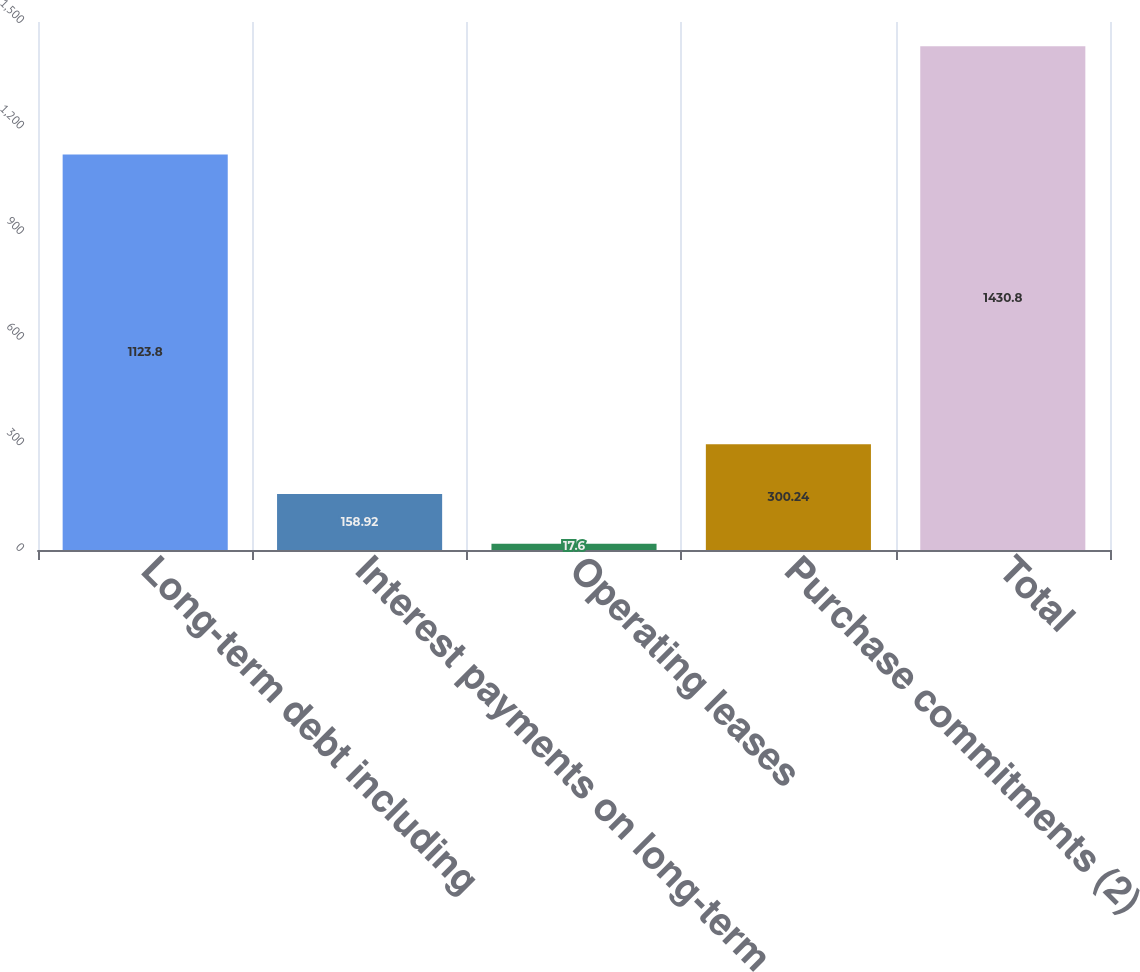Convert chart. <chart><loc_0><loc_0><loc_500><loc_500><bar_chart><fcel>Long-term debt including<fcel>Interest payments on long-term<fcel>Operating leases<fcel>Purchase commitments (2)<fcel>Total<nl><fcel>1123.8<fcel>158.92<fcel>17.6<fcel>300.24<fcel>1430.8<nl></chart> 